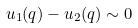Convert formula to latex. <formula><loc_0><loc_0><loc_500><loc_500>u _ { 1 } ( q ) - u _ { 2 } ( q ) \sim 0</formula> 